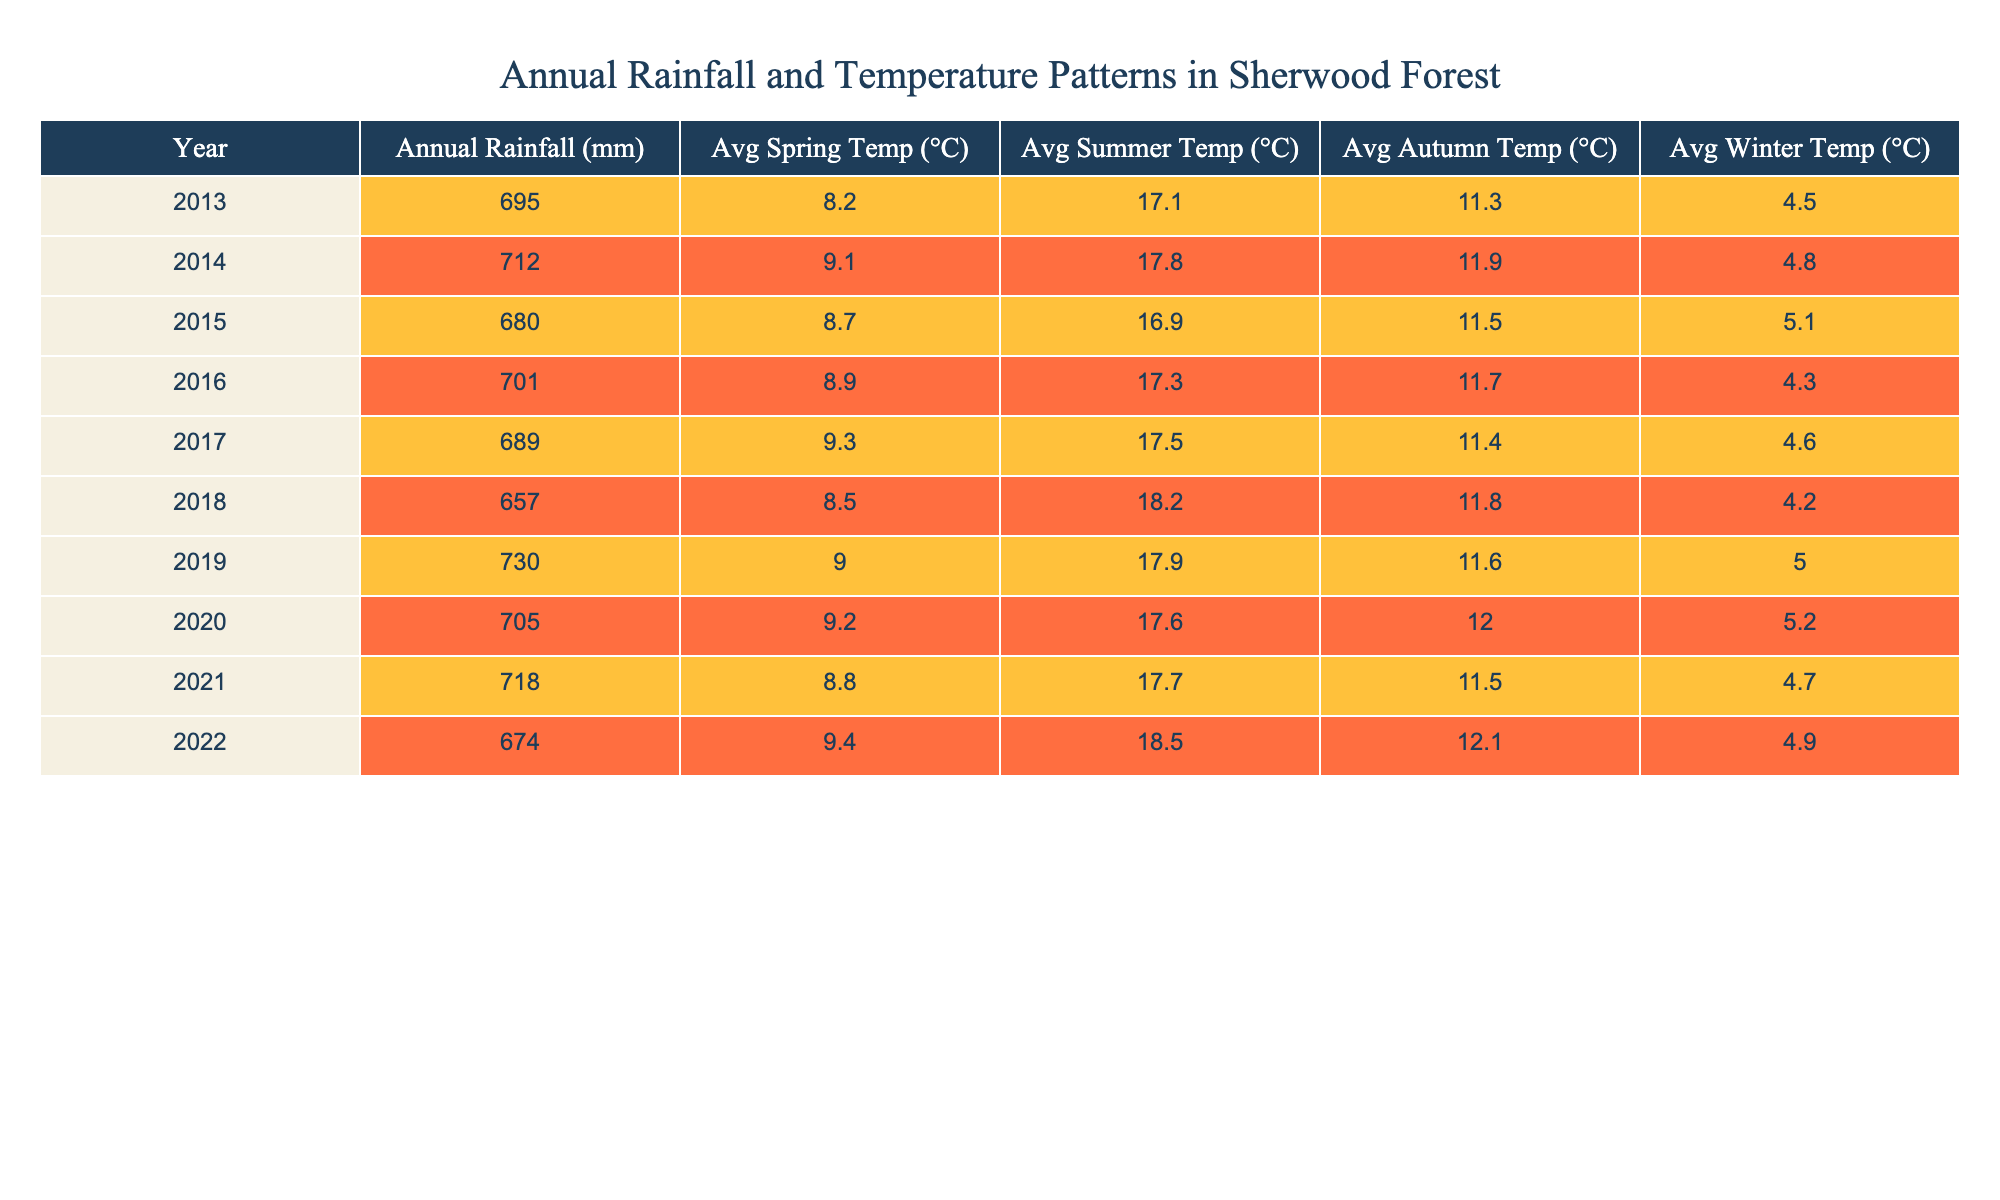What was the annual rainfall in 2019? The table shows the data for each year, and under the column for Annual Rainfall, the value for 2019 is 730 mm.
Answer: 730 mm Which year had the highest average summer temperature? Looking at the Avg Summer Temp column, we see that the highest temperature is 18.5°C in 2022.
Answer: 2022 What is the average annual rainfall over the last decade? To find the average annual rainfall, we sum up the rainfall from 2013 to 2022: (695 + 712 + 680 + 701 + 689 + 657 + 730 + 705 + 718 + 674) = 6839 mm. Then divide by 10 years to get 683.9 mm.
Answer: 683.9 mm Was 2016 a wetter year than 2018? Comparing the Annual Rainfall values, 2016 had 701 mm while 2018 had 657 mm, so 2016 was indeed wetter.
Answer: Yes In which year did the lowest average spring temperature occur? The Avg Spring Temp column shows a minimum of 8.2°C for the year 2013, which is the lowest value across the decade.
Answer: 2013 What was the difference in average autumn temperatures between 2014 and 2022? From the Avg Autumn Temp column, 2014 had 11.9°C and 2022 had 12.1°C. The difference is 12.1°C - 11.9°C = 0.2°C.
Answer: 0.2°C Which years had an average winter temperature above 5°C? The Avg Winter Temp values above 5°C are for the years 2015, 2020, and 2022 with temperatures of 5.1°C, 5.2°C, and 4.9°C respectively. So only 2020 is above 5°C.
Answer: 2020 What is the trend in annual rainfall over the last decade? The rainfall data shows some fluctuations but starts from 695 mm in 2013 and ends at 674 mm in 2022, indicating a slight decline overall.
Answer: Slight decline Which season had the highest average temperature in 2019? In 2019, the Avg Summer Temp was the highest among the seasonal temperatures recorded that year, at 17.9°C.
Answer: Summer Was there a year where the average spring temperature was equal to or greater than 9°C? By checking the Avg Spring Temp column, the years 2014, 2017, and 2022 all have temperatures 9°C or higher.
Answer: Yes 